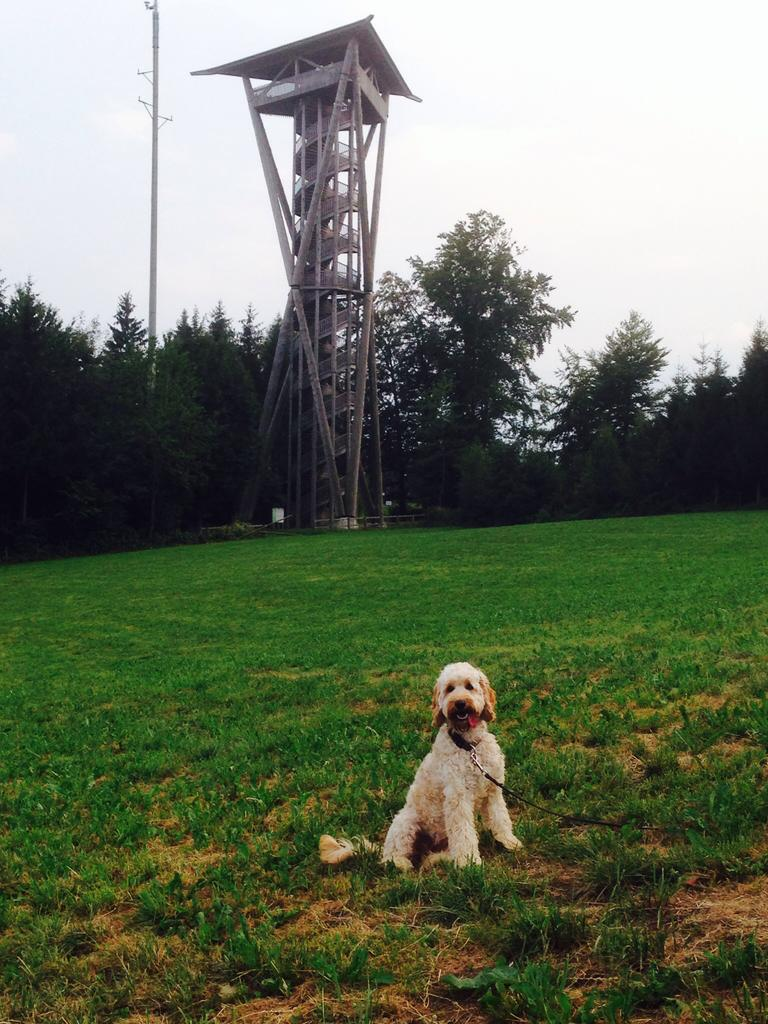What type of animal is present in the image? There is a dog in the image. What structure can be seen in the image? There is an iron frame in the image. What type of vegetation is visible in the image? There are trees in the image. What is visible at the top of the image? The sky is visible at the top of the image. What type of breakfast is being served on the iron frame in the image? There is no breakfast present in the image, and the iron frame is not serving any food. Can you tell me how many ants are crawling on the dog in the image? There are no ants present on the dog in the image. 